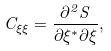Convert formula to latex. <formula><loc_0><loc_0><loc_500><loc_500>C _ { \xi \xi } = \frac { \partial ^ { 2 } S } { \partial { \xi ^ { * } } \partial \xi } ,</formula> 